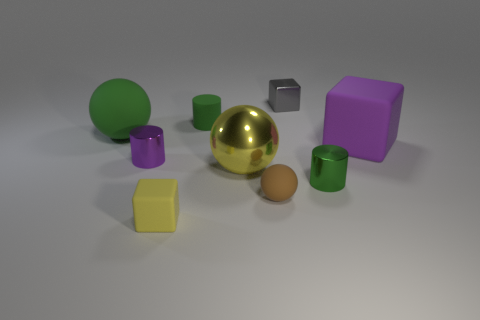Subtract all purple cubes. How many cubes are left? 2 Subtract all gray blocks. How many blocks are left? 2 Subtract all balls. How many objects are left? 6 Add 7 yellow shiny balls. How many yellow shiny balls exist? 8 Add 1 small balls. How many objects exist? 10 Subtract 0 red spheres. How many objects are left? 9 Subtract 1 spheres. How many spheres are left? 2 Subtract all purple blocks. Subtract all cyan cylinders. How many blocks are left? 2 Subtract all brown blocks. How many yellow spheres are left? 1 Subtract all tiny yellow things. Subtract all spheres. How many objects are left? 5 